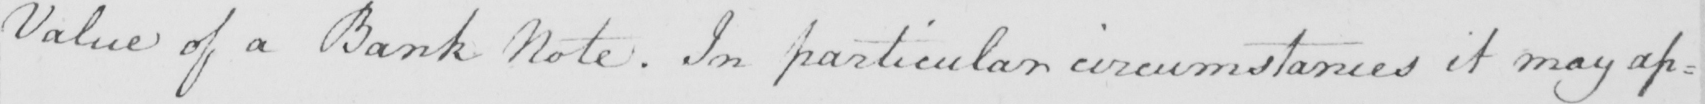Can you read and transcribe this handwriting? Value of a Bank Note . In particular circumstances it may ap : 